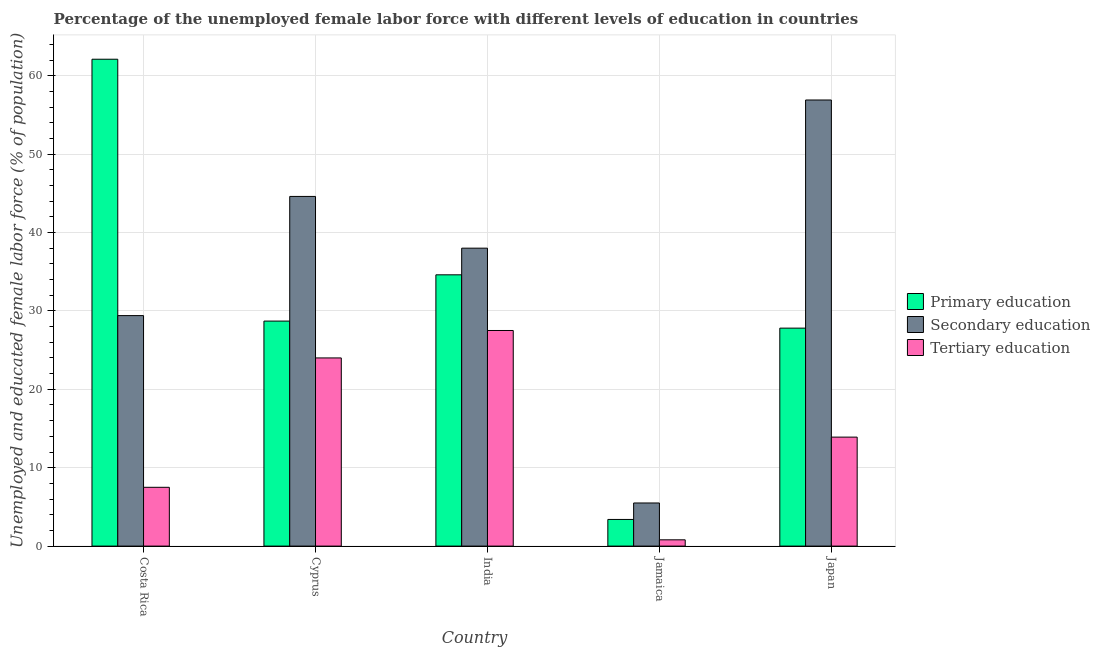How many different coloured bars are there?
Your response must be concise. 3. How many groups of bars are there?
Your answer should be very brief. 5. Are the number of bars per tick equal to the number of legend labels?
Your response must be concise. Yes. Are the number of bars on each tick of the X-axis equal?
Your response must be concise. Yes. What is the percentage of female labor force who received secondary education in Costa Rica?
Your answer should be compact. 29.4. Across all countries, what is the minimum percentage of female labor force who received tertiary education?
Make the answer very short. 0.8. In which country was the percentage of female labor force who received secondary education minimum?
Offer a very short reply. Jamaica. What is the total percentage of female labor force who received tertiary education in the graph?
Ensure brevity in your answer.  73.7. What is the difference between the percentage of female labor force who received primary education in Costa Rica and that in Cyprus?
Your answer should be compact. 33.4. What is the difference between the percentage of female labor force who received tertiary education in Costa Rica and the percentage of female labor force who received primary education in Jamaica?
Provide a short and direct response. 4.1. What is the average percentage of female labor force who received tertiary education per country?
Offer a terse response. 14.74. What is the difference between the percentage of female labor force who received secondary education and percentage of female labor force who received tertiary education in Jamaica?
Provide a succinct answer. 4.7. In how many countries, is the percentage of female labor force who received secondary education greater than 50 %?
Make the answer very short. 1. What is the ratio of the percentage of female labor force who received primary education in India to that in Japan?
Your answer should be very brief. 1.24. Is the difference between the percentage of female labor force who received secondary education in Costa Rica and Cyprus greater than the difference between the percentage of female labor force who received tertiary education in Costa Rica and Cyprus?
Ensure brevity in your answer.  Yes. What is the difference between the highest and the lowest percentage of female labor force who received secondary education?
Give a very brief answer. 51.4. What does the 1st bar from the left in Costa Rica represents?
Your response must be concise. Primary education. What does the 3rd bar from the right in Jamaica represents?
Ensure brevity in your answer.  Primary education. Are the values on the major ticks of Y-axis written in scientific E-notation?
Your response must be concise. No. Does the graph contain any zero values?
Provide a succinct answer. No. Does the graph contain grids?
Your answer should be compact. Yes. How many legend labels are there?
Your response must be concise. 3. What is the title of the graph?
Your response must be concise. Percentage of the unemployed female labor force with different levels of education in countries. What is the label or title of the Y-axis?
Offer a very short reply. Unemployed and educated female labor force (% of population). What is the Unemployed and educated female labor force (% of population) of Primary education in Costa Rica?
Keep it short and to the point. 62.1. What is the Unemployed and educated female labor force (% of population) in Secondary education in Costa Rica?
Provide a succinct answer. 29.4. What is the Unemployed and educated female labor force (% of population) of Tertiary education in Costa Rica?
Your response must be concise. 7.5. What is the Unemployed and educated female labor force (% of population) in Primary education in Cyprus?
Offer a terse response. 28.7. What is the Unemployed and educated female labor force (% of population) in Secondary education in Cyprus?
Keep it short and to the point. 44.6. What is the Unemployed and educated female labor force (% of population) of Primary education in India?
Give a very brief answer. 34.6. What is the Unemployed and educated female labor force (% of population) in Secondary education in India?
Provide a succinct answer. 38. What is the Unemployed and educated female labor force (% of population) in Primary education in Jamaica?
Offer a terse response. 3.4. What is the Unemployed and educated female labor force (% of population) in Secondary education in Jamaica?
Give a very brief answer. 5.5. What is the Unemployed and educated female labor force (% of population) of Tertiary education in Jamaica?
Make the answer very short. 0.8. What is the Unemployed and educated female labor force (% of population) of Primary education in Japan?
Give a very brief answer. 27.8. What is the Unemployed and educated female labor force (% of population) in Secondary education in Japan?
Provide a succinct answer. 56.9. What is the Unemployed and educated female labor force (% of population) in Tertiary education in Japan?
Keep it short and to the point. 13.9. Across all countries, what is the maximum Unemployed and educated female labor force (% of population) of Primary education?
Give a very brief answer. 62.1. Across all countries, what is the maximum Unemployed and educated female labor force (% of population) of Secondary education?
Ensure brevity in your answer.  56.9. Across all countries, what is the maximum Unemployed and educated female labor force (% of population) of Tertiary education?
Your response must be concise. 27.5. Across all countries, what is the minimum Unemployed and educated female labor force (% of population) of Primary education?
Your answer should be very brief. 3.4. Across all countries, what is the minimum Unemployed and educated female labor force (% of population) in Secondary education?
Keep it short and to the point. 5.5. Across all countries, what is the minimum Unemployed and educated female labor force (% of population) of Tertiary education?
Your answer should be compact. 0.8. What is the total Unemployed and educated female labor force (% of population) in Primary education in the graph?
Make the answer very short. 156.6. What is the total Unemployed and educated female labor force (% of population) of Secondary education in the graph?
Keep it short and to the point. 174.4. What is the total Unemployed and educated female labor force (% of population) of Tertiary education in the graph?
Your response must be concise. 73.7. What is the difference between the Unemployed and educated female labor force (% of population) of Primary education in Costa Rica and that in Cyprus?
Your response must be concise. 33.4. What is the difference between the Unemployed and educated female labor force (% of population) in Secondary education in Costa Rica and that in Cyprus?
Offer a terse response. -15.2. What is the difference between the Unemployed and educated female labor force (% of population) of Tertiary education in Costa Rica and that in Cyprus?
Offer a very short reply. -16.5. What is the difference between the Unemployed and educated female labor force (% of population) in Tertiary education in Costa Rica and that in India?
Provide a succinct answer. -20. What is the difference between the Unemployed and educated female labor force (% of population) of Primary education in Costa Rica and that in Jamaica?
Your response must be concise. 58.7. What is the difference between the Unemployed and educated female labor force (% of population) of Secondary education in Costa Rica and that in Jamaica?
Give a very brief answer. 23.9. What is the difference between the Unemployed and educated female labor force (% of population) in Tertiary education in Costa Rica and that in Jamaica?
Your answer should be compact. 6.7. What is the difference between the Unemployed and educated female labor force (% of population) in Primary education in Costa Rica and that in Japan?
Provide a short and direct response. 34.3. What is the difference between the Unemployed and educated female labor force (% of population) of Secondary education in Costa Rica and that in Japan?
Give a very brief answer. -27.5. What is the difference between the Unemployed and educated female labor force (% of population) in Tertiary education in Costa Rica and that in Japan?
Your answer should be compact. -6.4. What is the difference between the Unemployed and educated female labor force (% of population) in Secondary education in Cyprus and that in India?
Offer a terse response. 6.6. What is the difference between the Unemployed and educated female labor force (% of population) in Tertiary education in Cyprus and that in India?
Make the answer very short. -3.5. What is the difference between the Unemployed and educated female labor force (% of population) of Primary education in Cyprus and that in Jamaica?
Your answer should be compact. 25.3. What is the difference between the Unemployed and educated female labor force (% of population) of Secondary education in Cyprus and that in Jamaica?
Offer a terse response. 39.1. What is the difference between the Unemployed and educated female labor force (% of population) of Tertiary education in Cyprus and that in Jamaica?
Keep it short and to the point. 23.2. What is the difference between the Unemployed and educated female labor force (% of population) in Primary education in Cyprus and that in Japan?
Offer a terse response. 0.9. What is the difference between the Unemployed and educated female labor force (% of population) in Tertiary education in Cyprus and that in Japan?
Provide a short and direct response. 10.1. What is the difference between the Unemployed and educated female labor force (% of population) of Primary education in India and that in Jamaica?
Provide a short and direct response. 31.2. What is the difference between the Unemployed and educated female labor force (% of population) in Secondary education in India and that in Jamaica?
Offer a terse response. 32.5. What is the difference between the Unemployed and educated female labor force (% of population) of Tertiary education in India and that in Jamaica?
Your response must be concise. 26.7. What is the difference between the Unemployed and educated female labor force (% of population) in Primary education in India and that in Japan?
Your response must be concise. 6.8. What is the difference between the Unemployed and educated female labor force (% of population) of Secondary education in India and that in Japan?
Make the answer very short. -18.9. What is the difference between the Unemployed and educated female labor force (% of population) of Tertiary education in India and that in Japan?
Your answer should be very brief. 13.6. What is the difference between the Unemployed and educated female labor force (% of population) in Primary education in Jamaica and that in Japan?
Your response must be concise. -24.4. What is the difference between the Unemployed and educated female labor force (% of population) of Secondary education in Jamaica and that in Japan?
Ensure brevity in your answer.  -51.4. What is the difference between the Unemployed and educated female labor force (% of population) of Primary education in Costa Rica and the Unemployed and educated female labor force (% of population) of Tertiary education in Cyprus?
Provide a short and direct response. 38.1. What is the difference between the Unemployed and educated female labor force (% of population) of Secondary education in Costa Rica and the Unemployed and educated female labor force (% of population) of Tertiary education in Cyprus?
Your response must be concise. 5.4. What is the difference between the Unemployed and educated female labor force (% of population) in Primary education in Costa Rica and the Unemployed and educated female labor force (% of population) in Secondary education in India?
Your answer should be compact. 24.1. What is the difference between the Unemployed and educated female labor force (% of population) of Primary education in Costa Rica and the Unemployed and educated female labor force (% of population) of Tertiary education in India?
Your answer should be compact. 34.6. What is the difference between the Unemployed and educated female labor force (% of population) in Secondary education in Costa Rica and the Unemployed and educated female labor force (% of population) in Tertiary education in India?
Your answer should be compact. 1.9. What is the difference between the Unemployed and educated female labor force (% of population) in Primary education in Costa Rica and the Unemployed and educated female labor force (% of population) in Secondary education in Jamaica?
Provide a short and direct response. 56.6. What is the difference between the Unemployed and educated female labor force (% of population) in Primary education in Costa Rica and the Unemployed and educated female labor force (% of population) in Tertiary education in Jamaica?
Your answer should be very brief. 61.3. What is the difference between the Unemployed and educated female labor force (% of population) of Secondary education in Costa Rica and the Unemployed and educated female labor force (% of population) of Tertiary education in Jamaica?
Give a very brief answer. 28.6. What is the difference between the Unemployed and educated female labor force (% of population) of Primary education in Costa Rica and the Unemployed and educated female labor force (% of population) of Secondary education in Japan?
Give a very brief answer. 5.2. What is the difference between the Unemployed and educated female labor force (% of population) of Primary education in Costa Rica and the Unemployed and educated female labor force (% of population) of Tertiary education in Japan?
Provide a succinct answer. 48.2. What is the difference between the Unemployed and educated female labor force (% of population) of Secondary education in Costa Rica and the Unemployed and educated female labor force (% of population) of Tertiary education in Japan?
Provide a short and direct response. 15.5. What is the difference between the Unemployed and educated female labor force (% of population) in Primary education in Cyprus and the Unemployed and educated female labor force (% of population) in Secondary education in India?
Provide a short and direct response. -9.3. What is the difference between the Unemployed and educated female labor force (% of population) of Primary education in Cyprus and the Unemployed and educated female labor force (% of population) of Tertiary education in India?
Ensure brevity in your answer.  1.2. What is the difference between the Unemployed and educated female labor force (% of population) in Primary education in Cyprus and the Unemployed and educated female labor force (% of population) in Secondary education in Jamaica?
Your response must be concise. 23.2. What is the difference between the Unemployed and educated female labor force (% of population) in Primary education in Cyprus and the Unemployed and educated female labor force (% of population) in Tertiary education in Jamaica?
Ensure brevity in your answer.  27.9. What is the difference between the Unemployed and educated female labor force (% of population) of Secondary education in Cyprus and the Unemployed and educated female labor force (% of population) of Tertiary education in Jamaica?
Provide a succinct answer. 43.8. What is the difference between the Unemployed and educated female labor force (% of population) in Primary education in Cyprus and the Unemployed and educated female labor force (% of population) in Secondary education in Japan?
Make the answer very short. -28.2. What is the difference between the Unemployed and educated female labor force (% of population) of Secondary education in Cyprus and the Unemployed and educated female labor force (% of population) of Tertiary education in Japan?
Give a very brief answer. 30.7. What is the difference between the Unemployed and educated female labor force (% of population) in Primary education in India and the Unemployed and educated female labor force (% of population) in Secondary education in Jamaica?
Your answer should be compact. 29.1. What is the difference between the Unemployed and educated female labor force (% of population) in Primary education in India and the Unemployed and educated female labor force (% of population) in Tertiary education in Jamaica?
Offer a very short reply. 33.8. What is the difference between the Unemployed and educated female labor force (% of population) of Secondary education in India and the Unemployed and educated female labor force (% of population) of Tertiary education in Jamaica?
Provide a short and direct response. 37.2. What is the difference between the Unemployed and educated female labor force (% of population) of Primary education in India and the Unemployed and educated female labor force (% of population) of Secondary education in Japan?
Offer a terse response. -22.3. What is the difference between the Unemployed and educated female labor force (% of population) in Primary education in India and the Unemployed and educated female labor force (% of population) in Tertiary education in Japan?
Provide a succinct answer. 20.7. What is the difference between the Unemployed and educated female labor force (% of population) in Secondary education in India and the Unemployed and educated female labor force (% of population) in Tertiary education in Japan?
Make the answer very short. 24.1. What is the difference between the Unemployed and educated female labor force (% of population) in Primary education in Jamaica and the Unemployed and educated female labor force (% of population) in Secondary education in Japan?
Your answer should be very brief. -53.5. What is the difference between the Unemployed and educated female labor force (% of population) of Secondary education in Jamaica and the Unemployed and educated female labor force (% of population) of Tertiary education in Japan?
Offer a terse response. -8.4. What is the average Unemployed and educated female labor force (% of population) of Primary education per country?
Your answer should be very brief. 31.32. What is the average Unemployed and educated female labor force (% of population) of Secondary education per country?
Keep it short and to the point. 34.88. What is the average Unemployed and educated female labor force (% of population) of Tertiary education per country?
Offer a terse response. 14.74. What is the difference between the Unemployed and educated female labor force (% of population) in Primary education and Unemployed and educated female labor force (% of population) in Secondary education in Costa Rica?
Give a very brief answer. 32.7. What is the difference between the Unemployed and educated female labor force (% of population) of Primary education and Unemployed and educated female labor force (% of population) of Tertiary education in Costa Rica?
Provide a short and direct response. 54.6. What is the difference between the Unemployed and educated female labor force (% of population) of Secondary education and Unemployed and educated female labor force (% of population) of Tertiary education in Costa Rica?
Offer a terse response. 21.9. What is the difference between the Unemployed and educated female labor force (% of population) of Primary education and Unemployed and educated female labor force (% of population) of Secondary education in Cyprus?
Offer a terse response. -15.9. What is the difference between the Unemployed and educated female labor force (% of population) in Secondary education and Unemployed and educated female labor force (% of population) in Tertiary education in Cyprus?
Offer a terse response. 20.6. What is the difference between the Unemployed and educated female labor force (% of population) of Primary education and Unemployed and educated female labor force (% of population) of Secondary education in India?
Offer a terse response. -3.4. What is the difference between the Unemployed and educated female labor force (% of population) of Primary education and Unemployed and educated female labor force (% of population) of Secondary education in Jamaica?
Give a very brief answer. -2.1. What is the difference between the Unemployed and educated female labor force (% of population) in Primary education and Unemployed and educated female labor force (% of population) in Secondary education in Japan?
Ensure brevity in your answer.  -29.1. What is the difference between the Unemployed and educated female labor force (% of population) of Secondary education and Unemployed and educated female labor force (% of population) of Tertiary education in Japan?
Your answer should be very brief. 43. What is the ratio of the Unemployed and educated female labor force (% of population) in Primary education in Costa Rica to that in Cyprus?
Give a very brief answer. 2.16. What is the ratio of the Unemployed and educated female labor force (% of population) in Secondary education in Costa Rica to that in Cyprus?
Your response must be concise. 0.66. What is the ratio of the Unemployed and educated female labor force (% of population) of Tertiary education in Costa Rica to that in Cyprus?
Ensure brevity in your answer.  0.31. What is the ratio of the Unemployed and educated female labor force (% of population) in Primary education in Costa Rica to that in India?
Offer a terse response. 1.79. What is the ratio of the Unemployed and educated female labor force (% of population) of Secondary education in Costa Rica to that in India?
Your response must be concise. 0.77. What is the ratio of the Unemployed and educated female labor force (% of population) in Tertiary education in Costa Rica to that in India?
Your answer should be compact. 0.27. What is the ratio of the Unemployed and educated female labor force (% of population) of Primary education in Costa Rica to that in Jamaica?
Offer a terse response. 18.26. What is the ratio of the Unemployed and educated female labor force (% of population) of Secondary education in Costa Rica to that in Jamaica?
Your response must be concise. 5.35. What is the ratio of the Unemployed and educated female labor force (% of population) of Tertiary education in Costa Rica to that in Jamaica?
Keep it short and to the point. 9.38. What is the ratio of the Unemployed and educated female labor force (% of population) of Primary education in Costa Rica to that in Japan?
Offer a terse response. 2.23. What is the ratio of the Unemployed and educated female labor force (% of population) of Secondary education in Costa Rica to that in Japan?
Your answer should be compact. 0.52. What is the ratio of the Unemployed and educated female labor force (% of population) of Tertiary education in Costa Rica to that in Japan?
Keep it short and to the point. 0.54. What is the ratio of the Unemployed and educated female labor force (% of population) of Primary education in Cyprus to that in India?
Give a very brief answer. 0.83. What is the ratio of the Unemployed and educated female labor force (% of population) of Secondary education in Cyprus to that in India?
Your answer should be compact. 1.17. What is the ratio of the Unemployed and educated female labor force (% of population) in Tertiary education in Cyprus to that in India?
Offer a very short reply. 0.87. What is the ratio of the Unemployed and educated female labor force (% of population) in Primary education in Cyprus to that in Jamaica?
Keep it short and to the point. 8.44. What is the ratio of the Unemployed and educated female labor force (% of population) in Secondary education in Cyprus to that in Jamaica?
Your answer should be compact. 8.11. What is the ratio of the Unemployed and educated female labor force (% of population) in Tertiary education in Cyprus to that in Jamaica?
Offer a terse response. 30. What is the ratio of the Unemployed and educated female labor force (% of population) in Primary education in Cyprus to that in Japan?
Your answer should be compact. 1.03. What is the ratio of the Unemployed and educated female labor force (% of population) in Secondary education in Cyprus to that in Japan?
Keep it short and to the point. 0.78. What is the ratio of the Unemployed and educated female labor force (% of population) of Tertiary education in Cyprus to that in Japan?
Offer a terse response. 1.73. What is the ratio of the Unemployed and educated female labor force (% of population) in Primary education in India to that in Jamaica?
Your answer should be very brief. 10.18. What is the ratio of the Unemployed and educated female labor force (% of population) of Secondary education in India to that in Jamaica?
Provide a succinct answer. 6.91. What is the ratio of the Unemployed and educated female labor force (% of population) in Tertiary education in India to that in Jamaica?
Give a very brief answer. 34.38. What is the ratio of the Unemployed and educated female labor force (% of population) of Primary education in India to that in Japan?
Provide a short and direct response. 1.24. What is the ratio of the Unemployed and educated female labor force (% of population) in Secondary education in India to that in Japan?
Keep it short and to the point. 0.67. What is the ratio of the Unemployed and educated female labor force (% of population) of Tertiary education in India to that in Japan?
Your answer should be compact. 1.98. What is the ratio of the Unemployed and educated female labor force (% of population) of Primary education in Jamaica to that in Japan?
Provide a short and direct response. 0.12. What is the ratio of the Unemployed and educated female labor force (% of population) of Secondary education in Jamaica to that in Japan?
Provide a succinct answer. 0.1. What is the ratio of the Unemployed and educated female labor force (% of population) in Tertiary education in Jamaica to that in Japan?
Provide a short and direct response. 0.06. What is the difference between the highest and the second highest Unemployed and educated female labor force (% of population) of Secondary education?
Your answer should be very brief. 12.3. What is the difference between the highest and the lowest Unemployed and educated female labor force (% of population) of Primary education?
Offer a terse response. 58.7. What is the difference between the highest and the lowest Unemployed and educated female labor force (% of population) in Secondary education?
Your response must be concise. 51.4. What is the difference between the highest and the lowest Unemployed and educated female labor force (% of population) of Tertiary education?
Give a very brief answer. 26.7. 